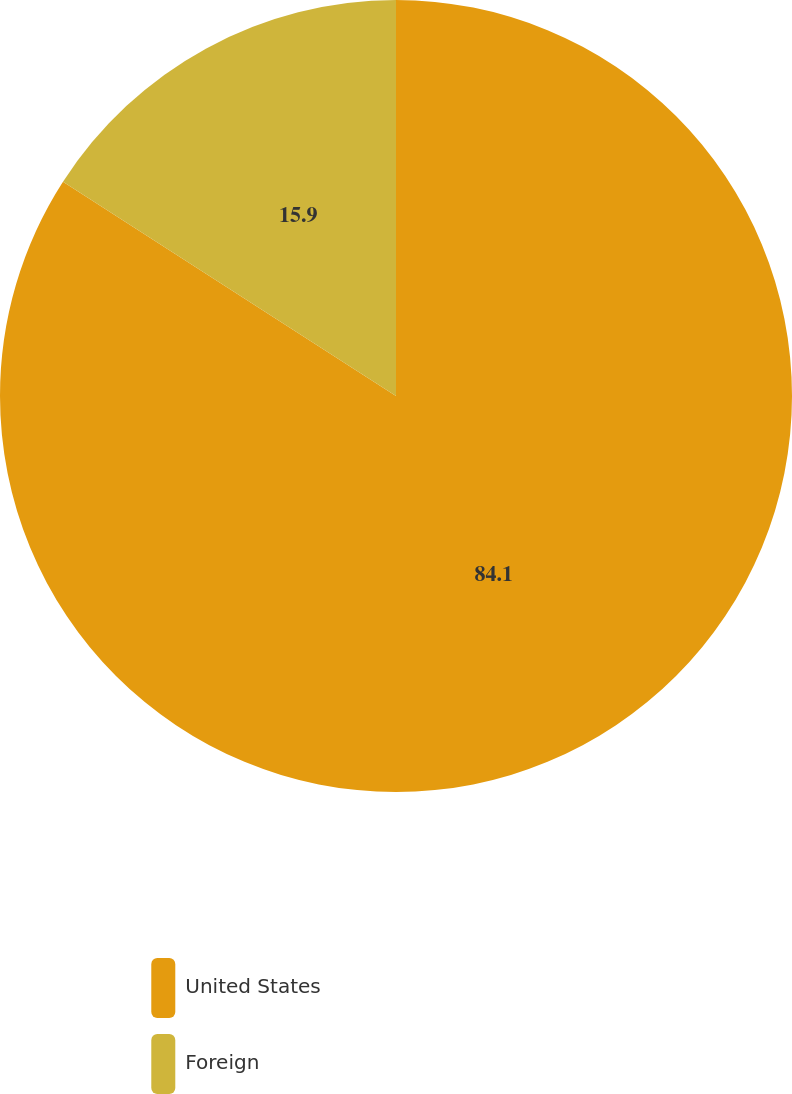<chart> <loc_0><loc_0><loc_500><loc_500><pie_chart><fcel>United States<fcel>Foreign<nl><fcel>84.1%<fcel>15.9%<nl></chart> 